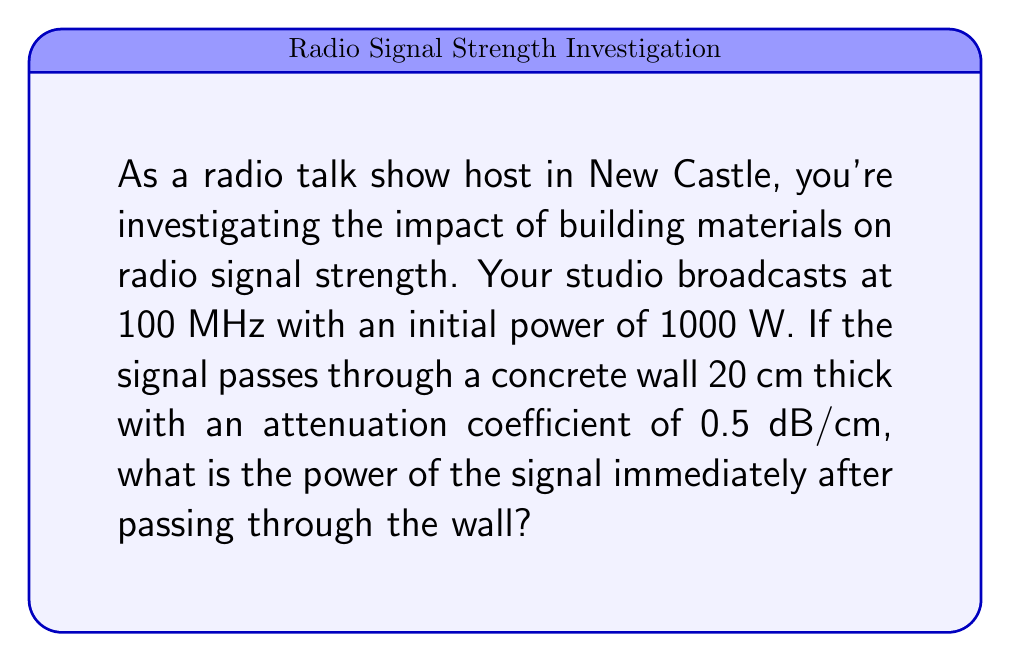Teach me how to tackle this problem. To solve this problem, we'll follow these steps:

1) The attenuation of radio signals through materials is often expressed in decibels (dB). The relationship between input power $P_i$ and output power $P_o$ in dB is given by:

   $$ \text{Attenuation (dB)} = 10 \log_{10}\left(\frac{P_i}{P_o}\right) $$

2) We're given:
   - Initial power $P_i = 1000$ W
   - Attenuation coefficient = 0.5 dB/cm
   - Wall thickness = 20 cm

3) Calculate total attenuation:
   $$ \text{Total Attenuation} = 0.5 \text{ dB/cm} \times 20 \text{ cm} = 10 \text{ dB} $$

4) Now, we can set up our equation:

   $$ 10 = 10 \log_{10}\left(\frac{1000}{P_o}\right) $$

5) Solve for $P_o$:

   $$ 1 = \log_{10}\left(\frac{1000}{P_o}\right) $$
   $$ 10^1 = \frac{1000}{P_o} $$
   $$ 10 = \frac{1000}{P_o} $$
   $$ P_o = \frac{1000}{10} = 100 \text{ W} $$

Thus, the power of the signal immediately after passing through the wall is 100 W.
Answer: 100 W 